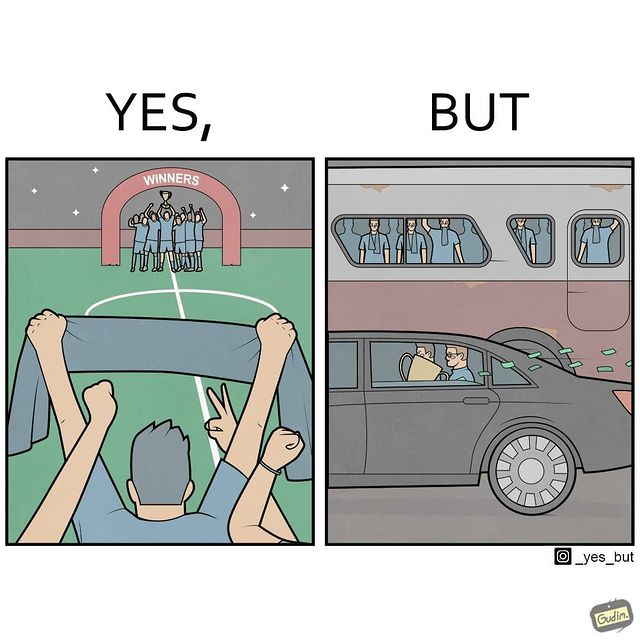Describe the content of this image. The image is ironical, as a team and its are all celebrating on the ground after winning the match, but after the match, the fans are standing in the bus uncomfortably, while the players are travelling inside a carring the cup as well as the prize money, which the fans did not get a dime of. 